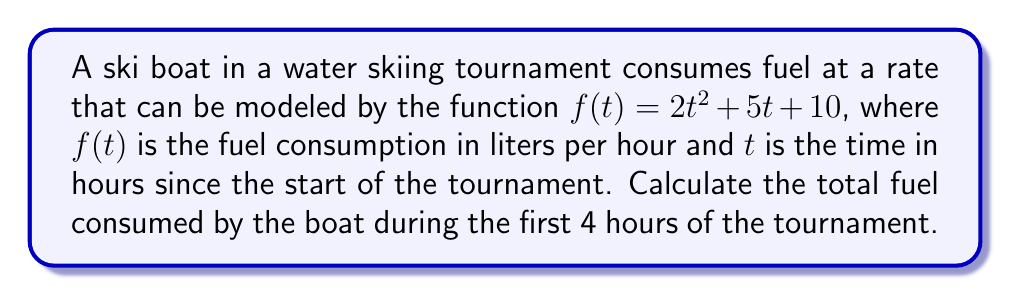Show me your answer to this math problem. To find the total fuel consumed over a period of time, we need to calculate the definite integral of the fuel consumption rate function from $t=0$ to $t=4$.

1. The fuel consumption rate function is given as:
   $f(t) = 2t^2 + 5t + 10$

2. We need to integrate this function from 0 to 4:
   $$\int_0^4 (2t^2 + 5t + 10) dt$$

3. Integrate each term:
   $$\left[\frac{2t^3}{3} + \frac{5t^2}{2} + 10t\right]_0^4$$

4. Evaluate the integral at the upper and lower bounds:
   $$\left(\frac{2(4^3)}{3} + \frac{5(4^2)}{2} + 10(4)\right) - \left(\frac{2(0^3)}{3} + \frac{5(0^2)}{2} + 10(0)\right)$$

5. Simplify:
   $$\left(\frac{128}{3} + 40 + 40\right) - (0)$$
   $$\frac{128}{3} + 80$$
   $$\frac{128 + 240}{3}$$
   $$\frac{368}{3}$$

6. Calculate the final result:
   $$122.67 \text{ liters (rounded to two decimal places)}$$
Answer: 122.67 liters 